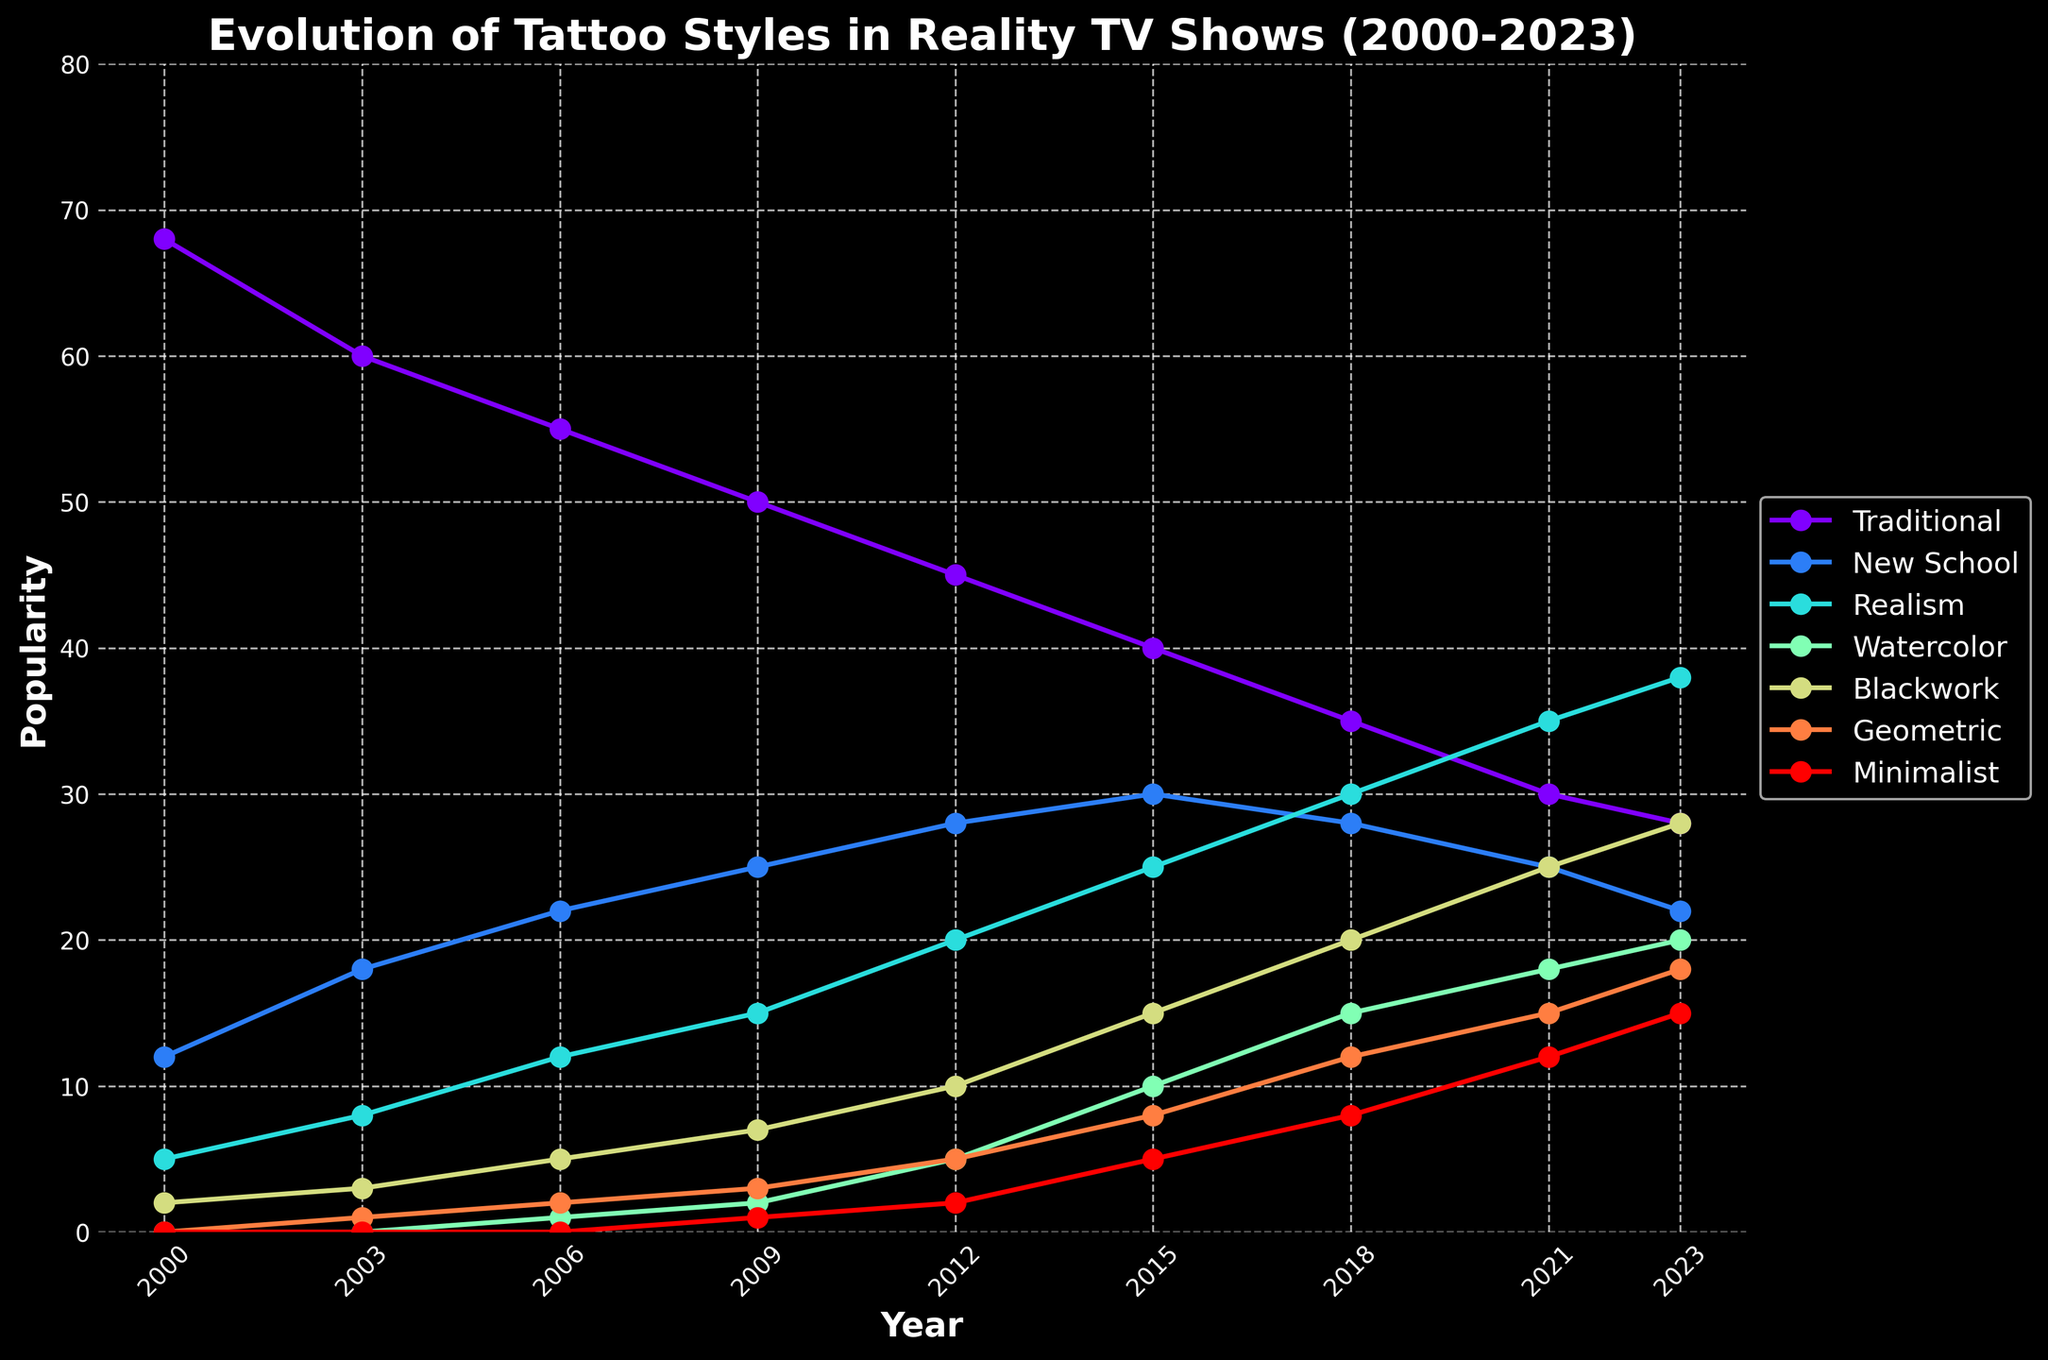What's the trend of the 'Traditional' tattoo style from 2000 to 2023? The 'Traditional' tattoo style starts at a popularity of 68 in 2000 and shows a decreasing trend, reaching 28 in 2023. This consistent decline indicates a decrease in popularity over the years.
Answer: Decreasing Which tattoo style has the largest increase in popularity from 2000 to 2023? To determine the largest increase, subtract the 2000 value from the 2023 value for each style: Traditional (-40), New School (10), Realism (33), Watercolor (20), Blackwork (26), Geometric (18), Minimalist (15). Realism has the largest increase, from 5 in 2000 to 38 in 2023.
Answer: Realism When did 'Watercolor' tattoos start appearing in reality TV shows? Referring to the figure, the popularity of ‘Watercolor’ tattoos starts at 0 and begins to appear around 2006, showing a slight increase at that time.
Answer: 2006 In which year did 'Minimalist' tattoos reach a popularity of 12? By observing the data points for 'Minimalist' tattoos, it shows a popularity of 12 in the year 2021.
Answer: 2021 Which tattoo styles are more popular than 'New School' in 2023? In 2023, 'New School' has a popularity of 22. Checking the other styles: Traditional (28), Realism (38), Watercolor (20), Blackwork (28), Geometric (18), Minimalist (15). ‘Traditional’, ‘Realism’, and ‘Blackwork’ are more popular.
Answer: Traditional, Realism, Blackwork How does the popularity of 'Geometric' tattoos in 2009 compare to that in 2023? In 2009, 'Geometric' tattoos have a popularity of 3, whereas in 2023, their popularity is 18. Subtracting these values, we see an increase of 15.
Answer: Increased by 15 By how much did the popularity of 'Realism' tattoos increase between 2009 and 2018? In 2009, the popularity of 'Realism' was 15, and in 2018, it was 30. Subtracting the two values, the increase is 15.
Answer: 15 Are there any tattoo styles whose popularity showed a consistent increase every recorded year? Examining the trends, 'Realism', 'Blackwork', and 'Geometric' show a consistent increase from their introduction without any declines across the years.
Answer: Realism, Blackwork, Geometric What is the difference in popularity between 'Traditional' and 'Realism' tattoos in 2023? In 2023, the 'Traditional' tattoo style has a popularity of 28, while 'Realism' has a popularity of 38. The difference is 38 - 28 = 10.
Answer: 10 